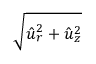Convert formula to latex. <formula><loc_0><loc_0><loc_500><loc_500>\sqrt { \hat { u } _ { r } ^ { 2 } + \hat { u } _ { z } ^ { 2 } }</formula> 